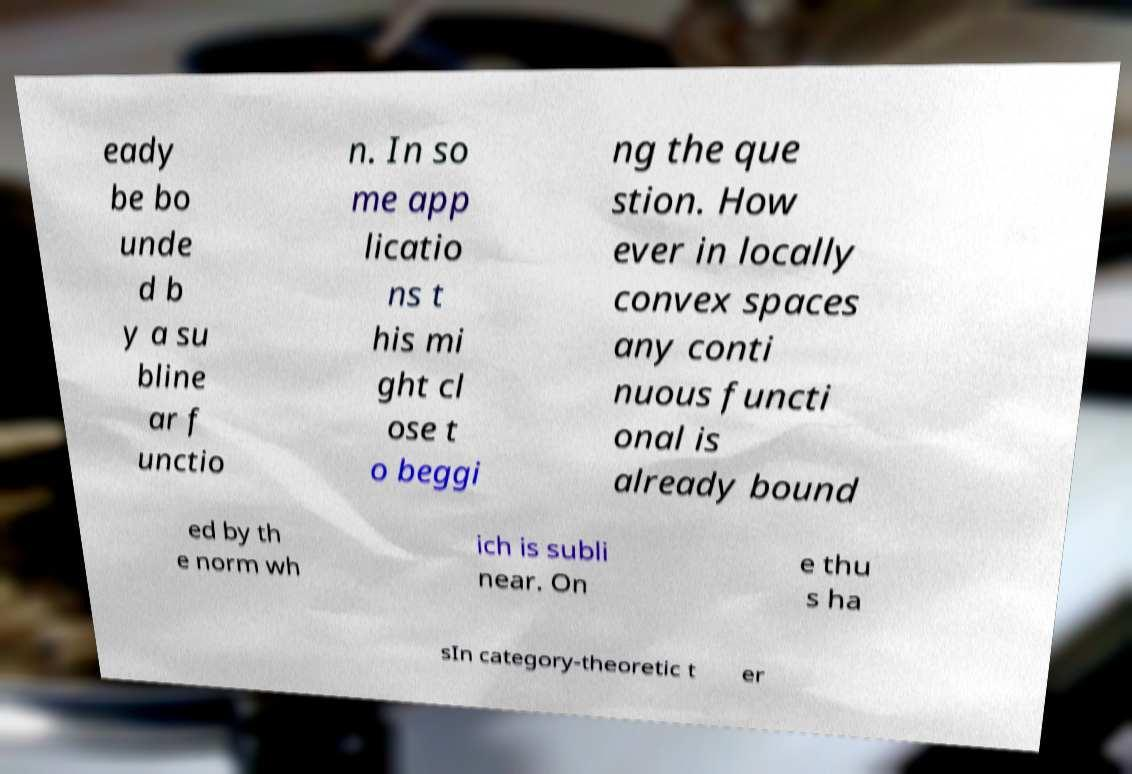Can you accurately transcribe the text from the provided image for me? eady be bo unde d b y a su bline ar f unctio n. In so me app licatio ns t his mi ght cl ose t o beggi ng the que stion. How ever in locally convex spaces any conti nuous functi onal is already bound ed by th e norm wh ich is subli near. On e thu s ha sIn category-theoretic t er 